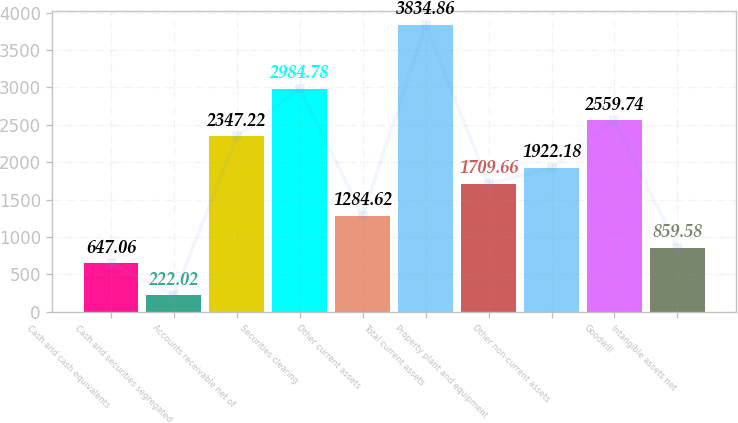Convert chart to OTSL. <chart><loc_0><loc_0><loc_500><loc_500><bar_chart><fcel>Cash and cash equivalents<fcel>Cash and securities segregated<fcel>Accounts receivable net of<fcel>Securities clearing<fcel>Other current assets<fcel>Total current assets<fcel>Property plant and equipment<fcel>Other non-current assets<fcel>Goodwill<fcel>Intangible assets net<nl><fcel>647.06<fcel>222.02<fcel>2347.22<fcel>2984.78<fcel>1284.62<fcel>3834.86<fcel>1709.66<fcel>1922.18<fcel>2559.74<fcel>859.58<nl></chart> 